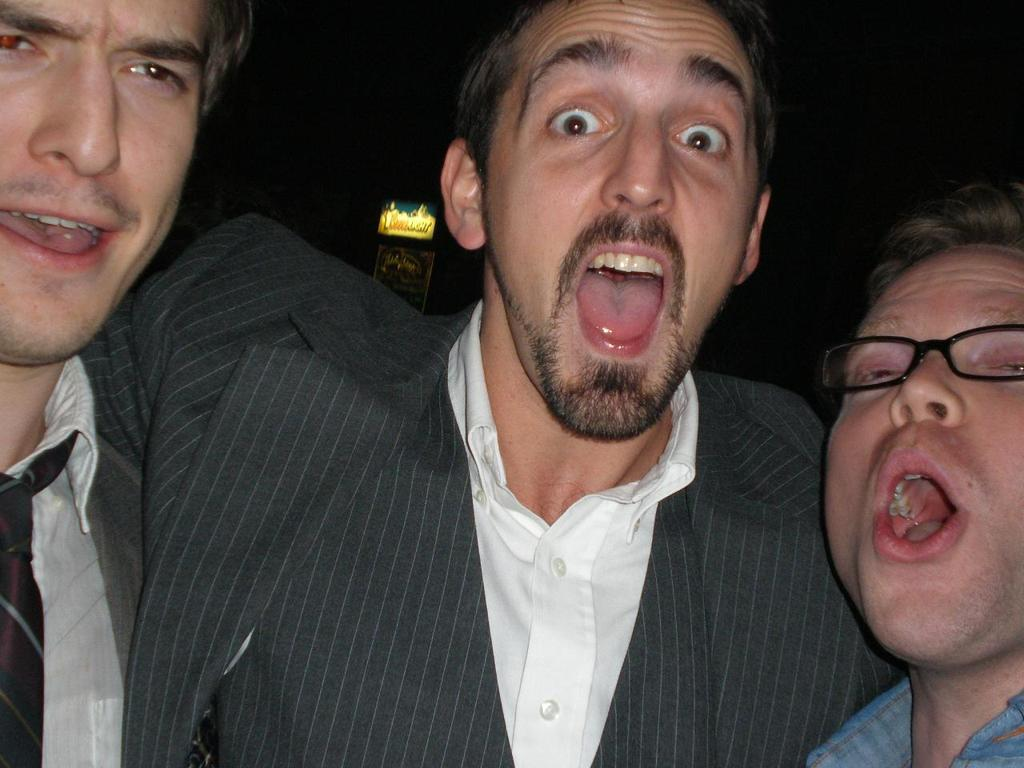How many people are in the image? There are three people in the image. What are the people doing in the image? The people have their mouths open. Can you describe the background of the image? The background of the image is dark. Is there anything else visible in the background besides the darkness? Yes, there is an object in the background of the image. What type of street can be seen in the image? There is no street present in the image. How many elbows can be seen in the image? The provided facts do not mention elbows, so it is impossible to determine the number of elbows in the image. 